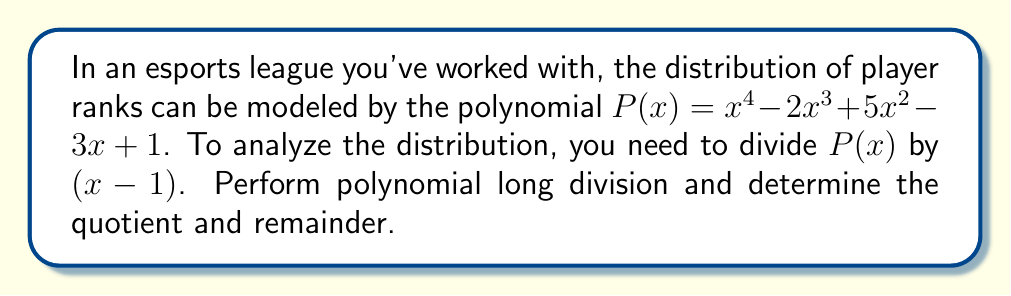Solve this math problem. Let's perform polynomial long division of $P(x) = x^4 - 2x^3 + 5x^2 - 3x + 1$ by $(x - 1)$:

$$\begin{array}{r}
x^3 + x^2 + 6x + 3 \\
x - 1 \enclose{longdiv}{x^4 - 2x^3 + 5x^2 - 3x + 1} \\
\underline{x^4 - x^3} \\
-x^3 + 5x^2 \\
\underline{-x^3 + x^2} \\
4x^2 - 3x \\
\underline{4x^2 - 4x} \\
x + 1 \\
\underline{x - 1} \\
2
\end{array}$$

Step 1: Divide $x^4$ by $x$, getting $x^3$. Multiply $(x-1)$ by $x^3$ and subtract.
Step 2: Bring down $-2x^3$. Divide $-x^3$ by $x$, getting $-x^2$. Multiply $(x-1)$ by $-x^2$ and subtract.
Step 3: Bring down $5x^2$. Divide $4x^2$ by $x$, getting $4x$. Multiply $(x-1)$ by $4x$ and subtract.
Step 4: Bring down $-3x$. Divide $x$ by $x$, getting $1$. Multiply $(x-1)$ by $1$ and subtract.
Step 5: Bring down $1$. The division is complete with a remainder of $2$.

Therefore, the quotient is $x^3 + x^2 + 6x + 3$ and the remainder is $2$.
Answer: Quotient: $x^3 + x^2 + 6x + 3$, Remainder: $2$ 